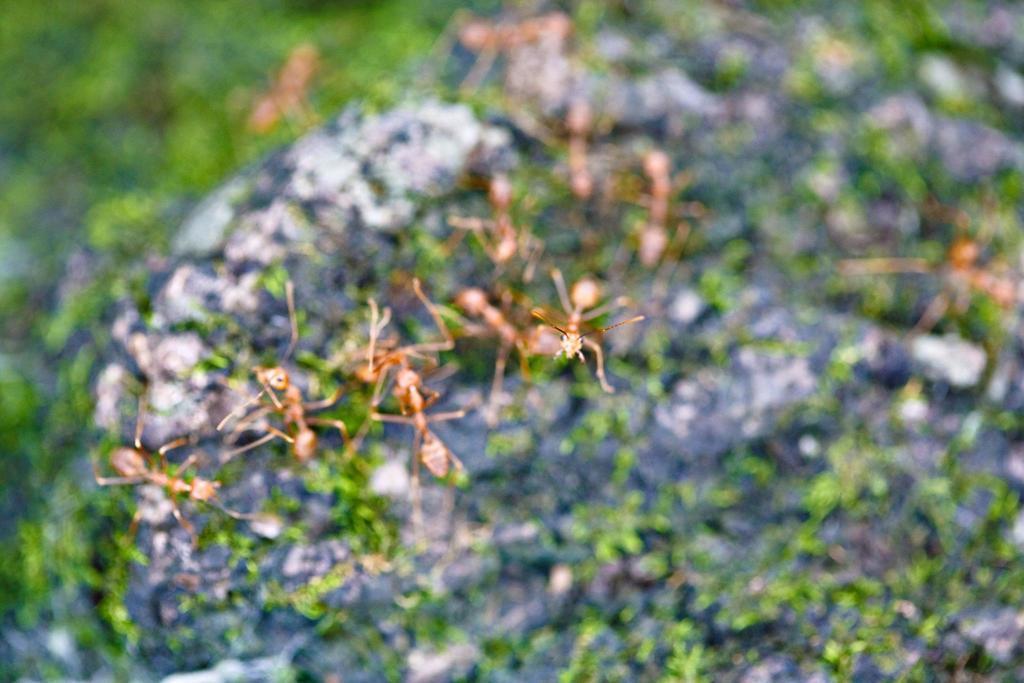In one or two sentences, can you explain what this image depicts? In this picture we can see a few ants. Background is blurry. 